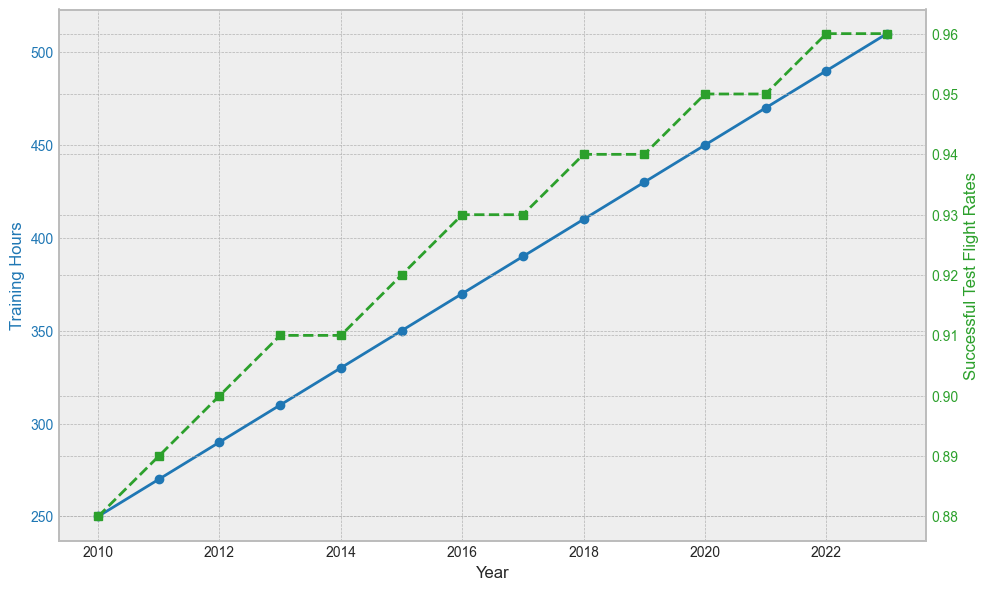What is the overall trend in Training Hours from 2010 to 2023? The Training Hours show a consistent upward trend over the years from 2010 to 2023. In 2010, the Training Hours were 250, and by 2023, they increased to 510. This indicates a steady increase in the amount of training pilots are receiving each year.
Answer: Consistent upward trend How does the trend in Successful Test Flight Rates compare to the trend in Training Hours? Both Training Hours and Successful Test Flight Rates show an upward trend from 2010 to 2023. However, while Training Hours increase more continuously, the Successful Test Flight Rates increase more gradually and have periods of plateauing, particularly between 2013-2014 and 2017-2018.
Answer: Both increase, but with different rates In which year is the difference between Training Hours and Successful Test Flight Rates the smallest? To find this, we need to look for the year where the difference between the Training Hours and the corresponding Successful Test Flight Rate is smallest. Both values are plotted on different scales, so this needs to be inferred visually by looking for the year where the two lines are closest to each other. 2013 appears to be the year where the difference is the smallest.
Answer: 2013 What is the average annual increase in Training Hours from 2010 to 2023? First, find the total increase in Training Hours from 2010 to 2023: 510 - 250 = 260 hours. Then, find the number of years: 2023 - 2010 = 13 years. Finally, divide the total increase by the number of years: 260 / 13 ≈ 20 hours per year.
Answer: 20 hours per year Which year shows the highest Successful Test Flight Rate, and what is the value? By examining the plot, the highest Successful Test Flight Rate can be found in the last year, 2023, and the value is 0.96.
Answer: 2023, 0.96 Was there any year where the Successful Test Flight Rate did not increase compared to the previous year? Yes, a visual examination of the plot reveals that the Successful Test Flight Rate did not increase from 2013 to 2014 and from 2017 to 2018.
Answer: Yes, 2013-2014 and 2017-2018 How does the increase in Successful Test Flight Rate from 2010 to 2023 compare to the increase in Training Hours over the same period? The increase in Training Hours from 2010 to 2023 is 510 - 250 = 260 hours. The increase in Successful Test Flight Rate from 2010 to 2023 is 0.96 - 0.88 = 0.08. Training Hours increased by 260 hours, showing a more pronounced rise compared to the 0.08 increase in Successful Test Flight Rate.
Answer: Training Hours increased more What is the average Successful Test Flight Rate over the years 2010 to 2023? To find the average Successful Test Flight Rate, add all the annual rates and divide by the number of years: (0.88 + 0.89 + 0.90 + 0.91 + 0.91 + 0.92 + 0.93 + 0.93 + 0.94 + 0.94 + 0.95 + 0.95 + 0.96 + 0.96) / 14 ≈ 0.924.
Answer: 0.924 By how much did the Training Hours and Successful Test Flight Rates increase between 2010 and 2023? Training Hours increased by 510 - 250 = 260 hours. Successful Test Flight Rates increased by 0.96 - 0.88 = 0.08.
Answer: 260 hours, 0.08 